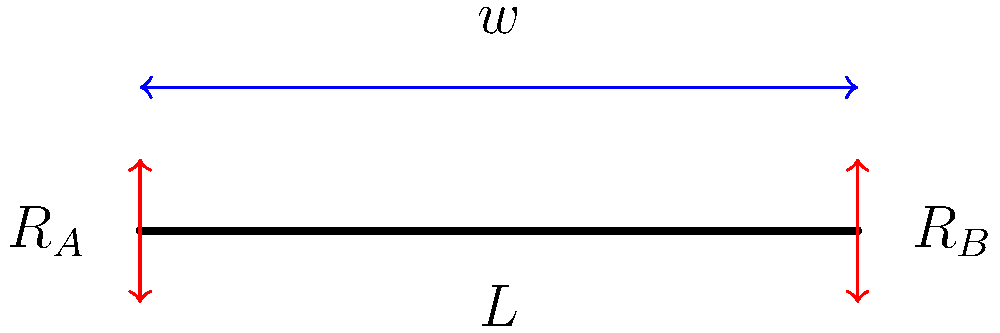As a fisherman who takes football players on team-building fishing trips, you notice that the fishing rods bend under load. Consider a simplified model of a fishing rod as a beam of length $L$ with a uniformly distributed load $w$ per unit length. What is the maximum bending moment $M_{max}$ in the rod? Let's approach this step-by-step:

1) First, we need to determine the reactions at the supports. Due to symmetry, we know that:

   $R_A = R_B = \frac{wL}{2}$

2) The total load on the beam is $wL$.

3) For a uniformly distributed load, the maximum bending moment occurs at the center of the beam.

4) To find the maximum bending moment, we can use the formula:

   $M_{max} = \frac{wL^2}{8}$

   This formula comes from analyzing the bending moment diagram for a simply supported beam with a uniformly distributed load.

5) The derivation of this formula involves:
   - Setting up the moment equation
   - Integrating the distributed load
   - Applying boundary conditions

6) This maximum bending moment occurs at the center of the beam (at $L/2$).

7) Understanding this helps in designing fishing rods that can withstand the loads they're subjected to during use, ensuring safety and performance for the football players during their team-building fishing trips.
Answer: $M_{max} = \frac{wL^2}{8}$ 